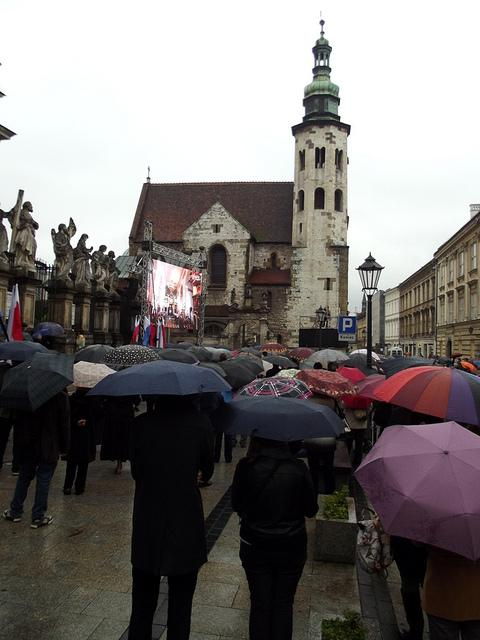Why are the people holding umbrellas? raining 